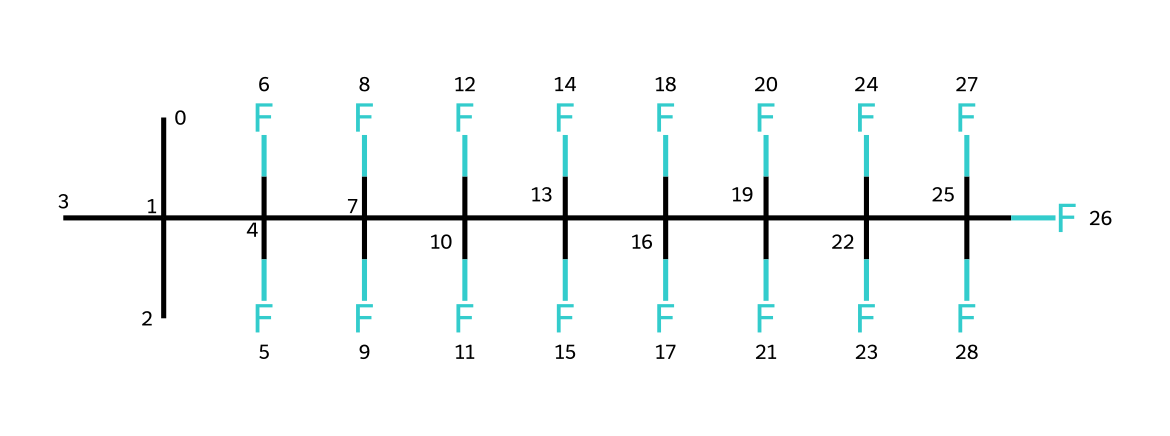How many carbon atoms are in this chemical? The SMILES representation contains multiple "C" characters, representing carbon atoms. Counting them reveals there are 8 carbon atoms in this chemical structure.
Answer: 8 How many fluorine atoms are in this chemical? The "F" characters in the SMILES indicate fluorine atoms. Upon counting, we find there are 12 fluorine atoms in the structure.
Answer: 12 What type of chemical is this? This chemical features a silane compound structure with fluorinated alkyl groups, typically known for its use in non-stick coatings.
Answer: silane What property does this chemical give to cookware? The heavy fluorination in this structure grants it excellent non-stick properties, making it ideal for cookware applications.
Answer: non-stick What functional groups are present in this chemical? The chemical primarily consists of silane (due to the silicon atom linked with multiple carbon and fluorine) — it is characterized by the presence of carbon and fluorine atoms.
Answer: silane How does the large number of fluorine atoms affect its properties? The extensive fluorination leads to a high electronegativity in the chemical, which contributes to low surface energy and non-stick characteristics in cookware.
Answer: low surface energy What is the main use of this chemical structure in everyday products? The combination of carbon and fluorine atoms in this structure is used mainly as a coating for cookware due to its non-stick properties.
Answer: cookware coating 